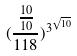<formula> <loc_0><loc_0><loc_500><loc_500>( \frac { \frac { 1 0 } { 1 0 } } { 1 1 8 } ) ^ { 3 ^ { \sqrt { 1 0 } } }</formula> 